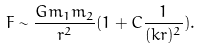Convert formula to latex. <formula><loc_0><loc_0><loc_500><loc_500>F \sim \frac { G m _ { 1 } m _ { 2 } } { r ^ { 2 } } ( 1 + C \frac { 1 } { ( k r ) ^ { 2 } } ) .</formula> 